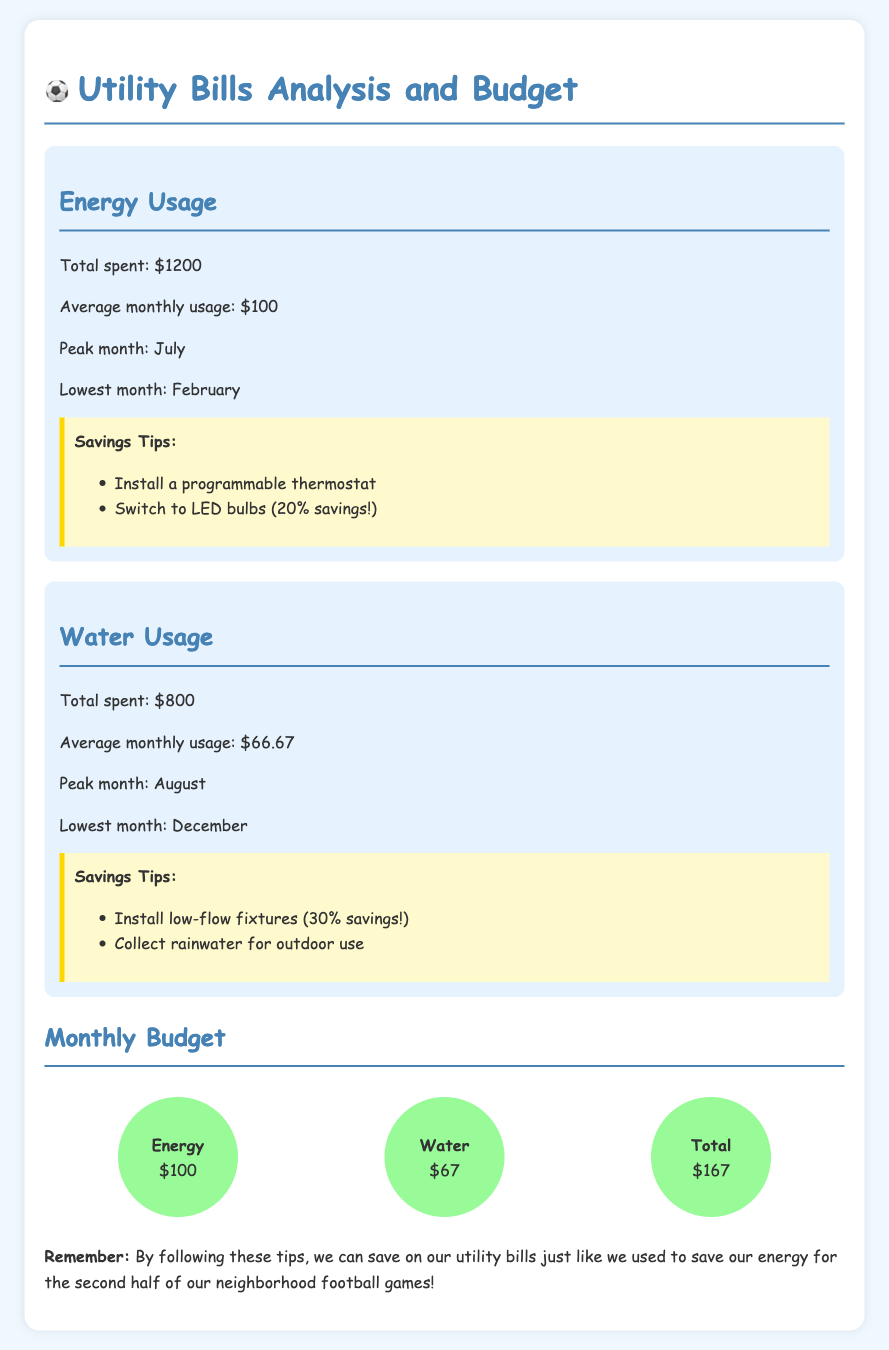what is the total spent on energy? The total spent on energy is provided in the document as $1200.
Answer: $1200 what is the peak month for water usage? The peak month for water usage is mentioned in the document as August.
Answer: August what is the average monthly water usage? The document states that the average monthly water usage is $66.67.
Answer: $66.67 what is the total spent on water? The total spent on water is given as $800 in the document.
Answer: $800 how much can be saved by switching to LED bulbs? The document notes that switching to LED bulbs can save 20%.
Answer: 20% which month had the lowest energy usage? The lowest month for energy usage is specified as February in the document.
Answer: February what are two savings tips for water usage? The savings tips for water usage mentioned are installing low-flow fixtures and collecting rainwater.
Answer: Install low-flow fixtures, collect rainwater what is the average monthly energy usage? The document indicates the average monthly energy usage is $100.
Answer: $100 what is the total monthly budget for utilities? The total monthly budget for utilities is calculated in the document as $167.
Answer: $167 